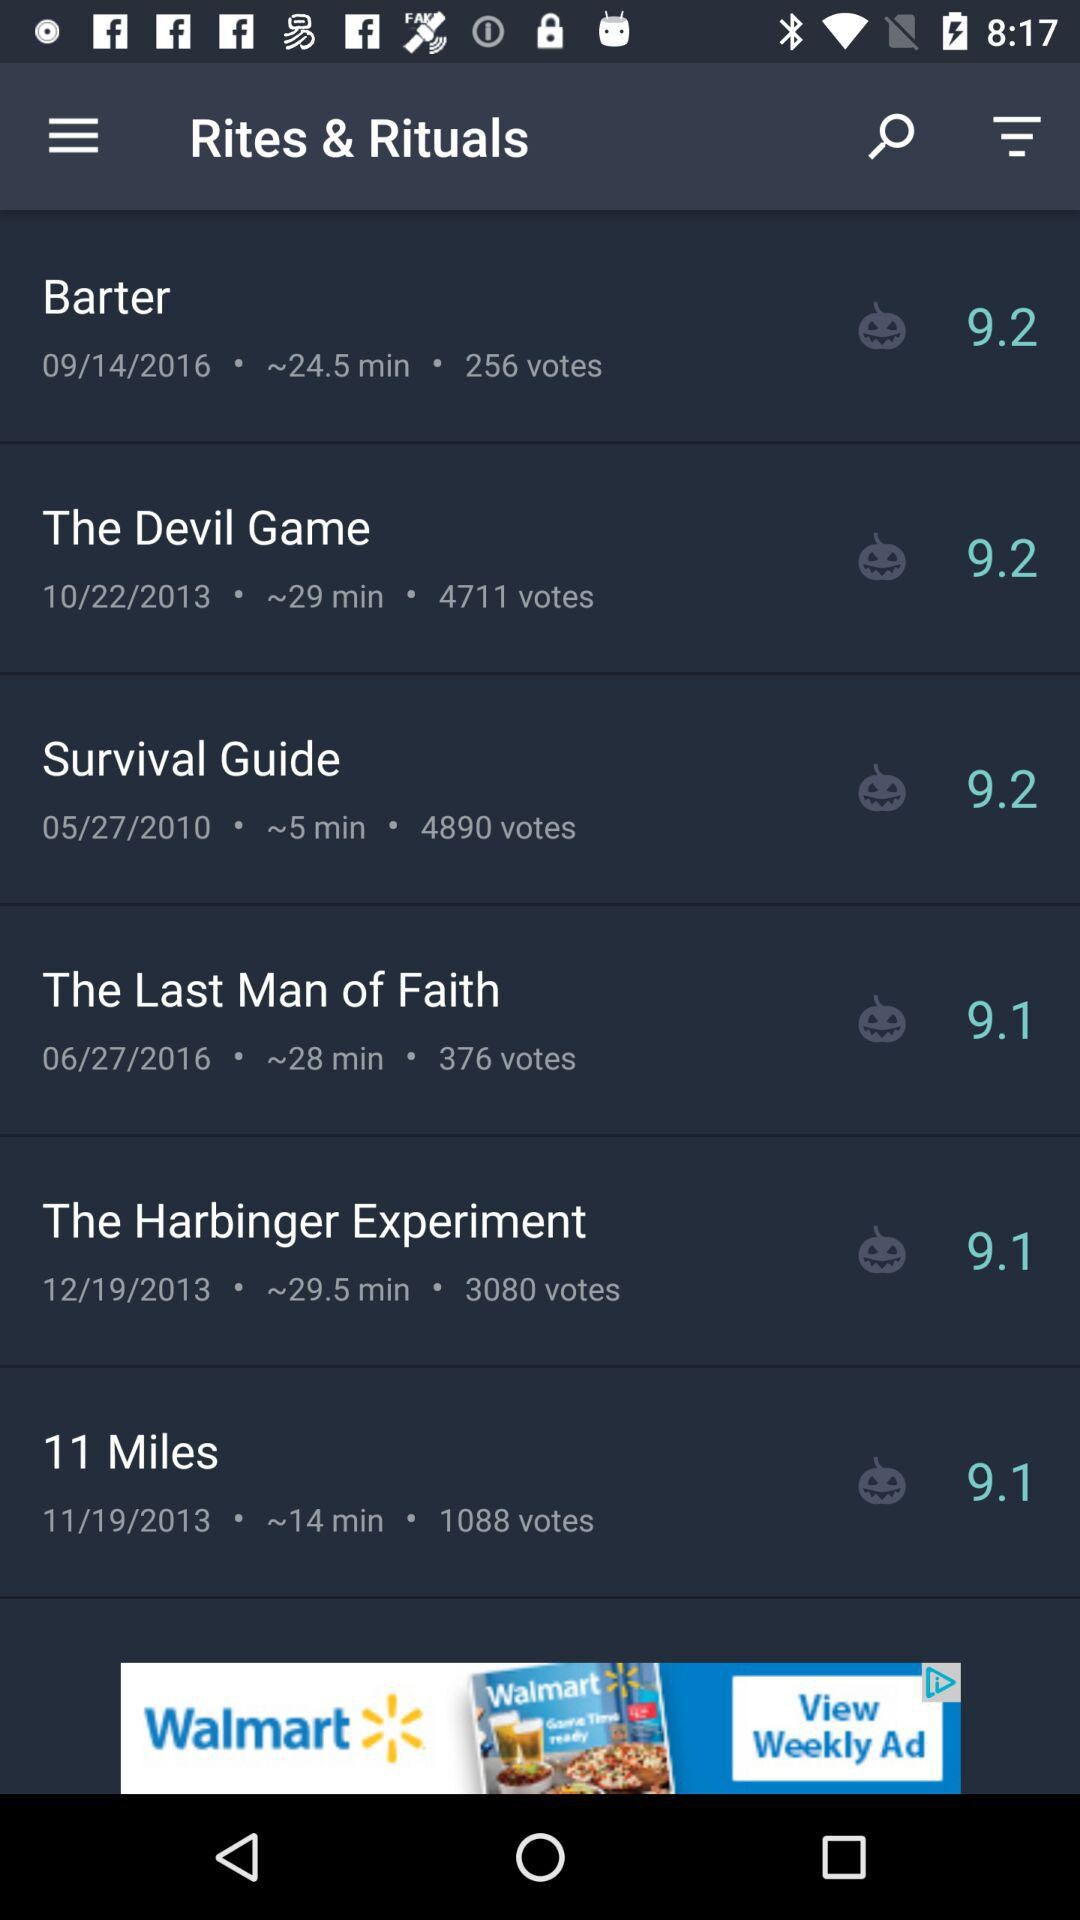How many votes are there for "11 Miles"? There are 1088 votes. 